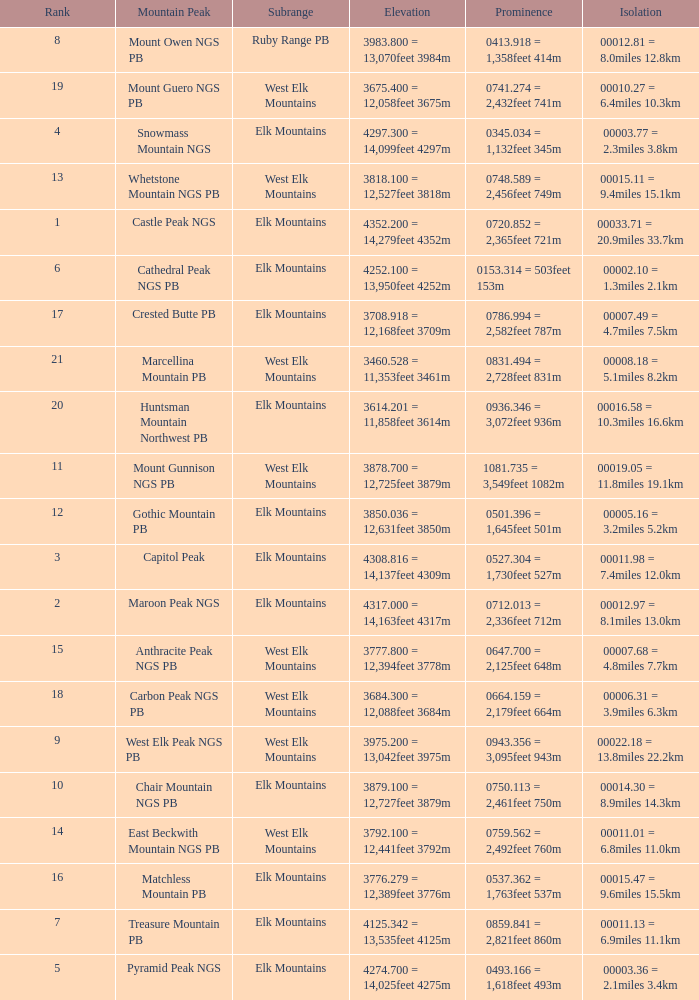Name the Rank of Rank Mountain Peak of crested butte pb? 17.0. 